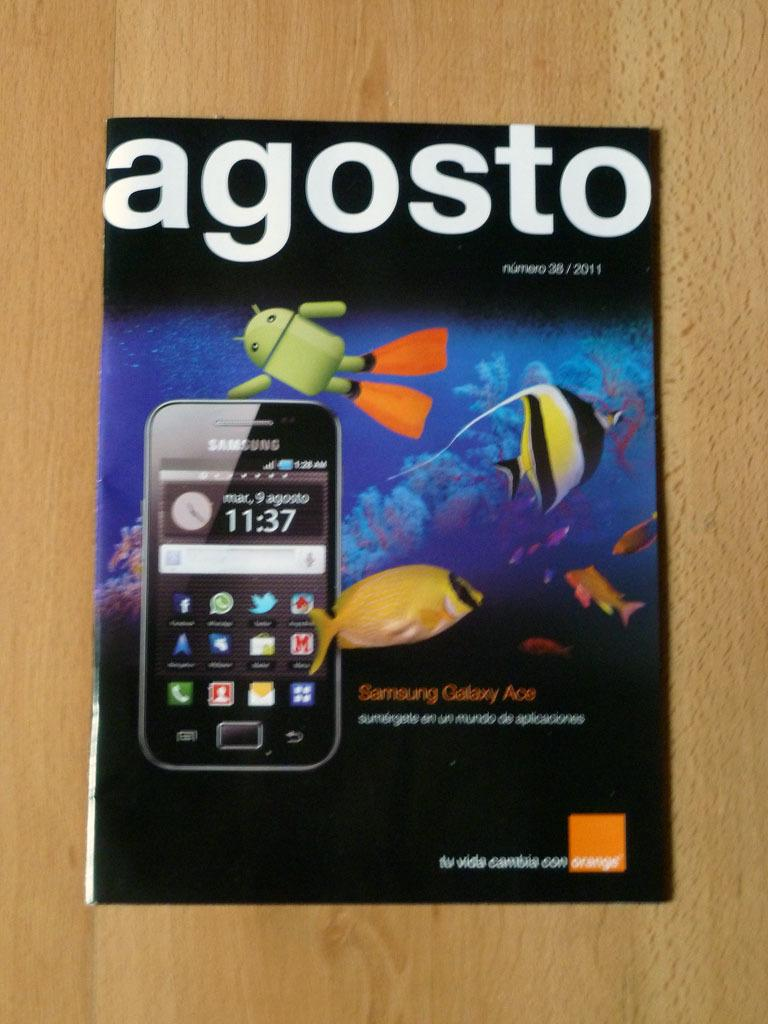<image>
Write a terse but informative summary of the picture. A agosto post with a cellphone on it and the time 11:37. 